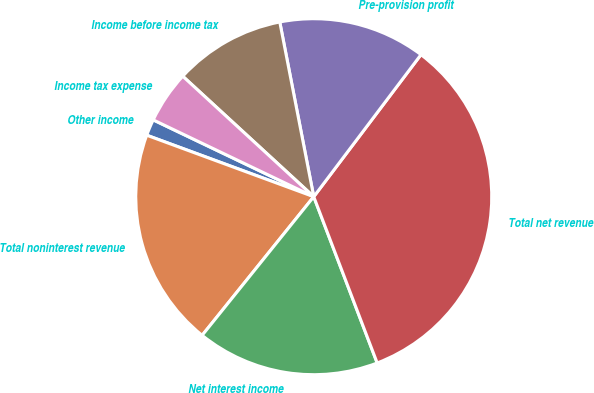Convert chart to OTSL. <chart><loc_0><loc_0><loc_500><loc_500><pie_chart><fcel>Other income<fcel>Total noninterest revenue<fcel>Net interest income<fcel>Total net revenue<fcel>Pre-provision profit<fcel>Income before income tax<fcel>Income tax expense<nl><fcel>1.49%<fcel>19.83%<fcel>16.59%<fcel>33.91%<fcel>13.35%<fcel>10.11%<fcel>4.73%<nl></chart> 